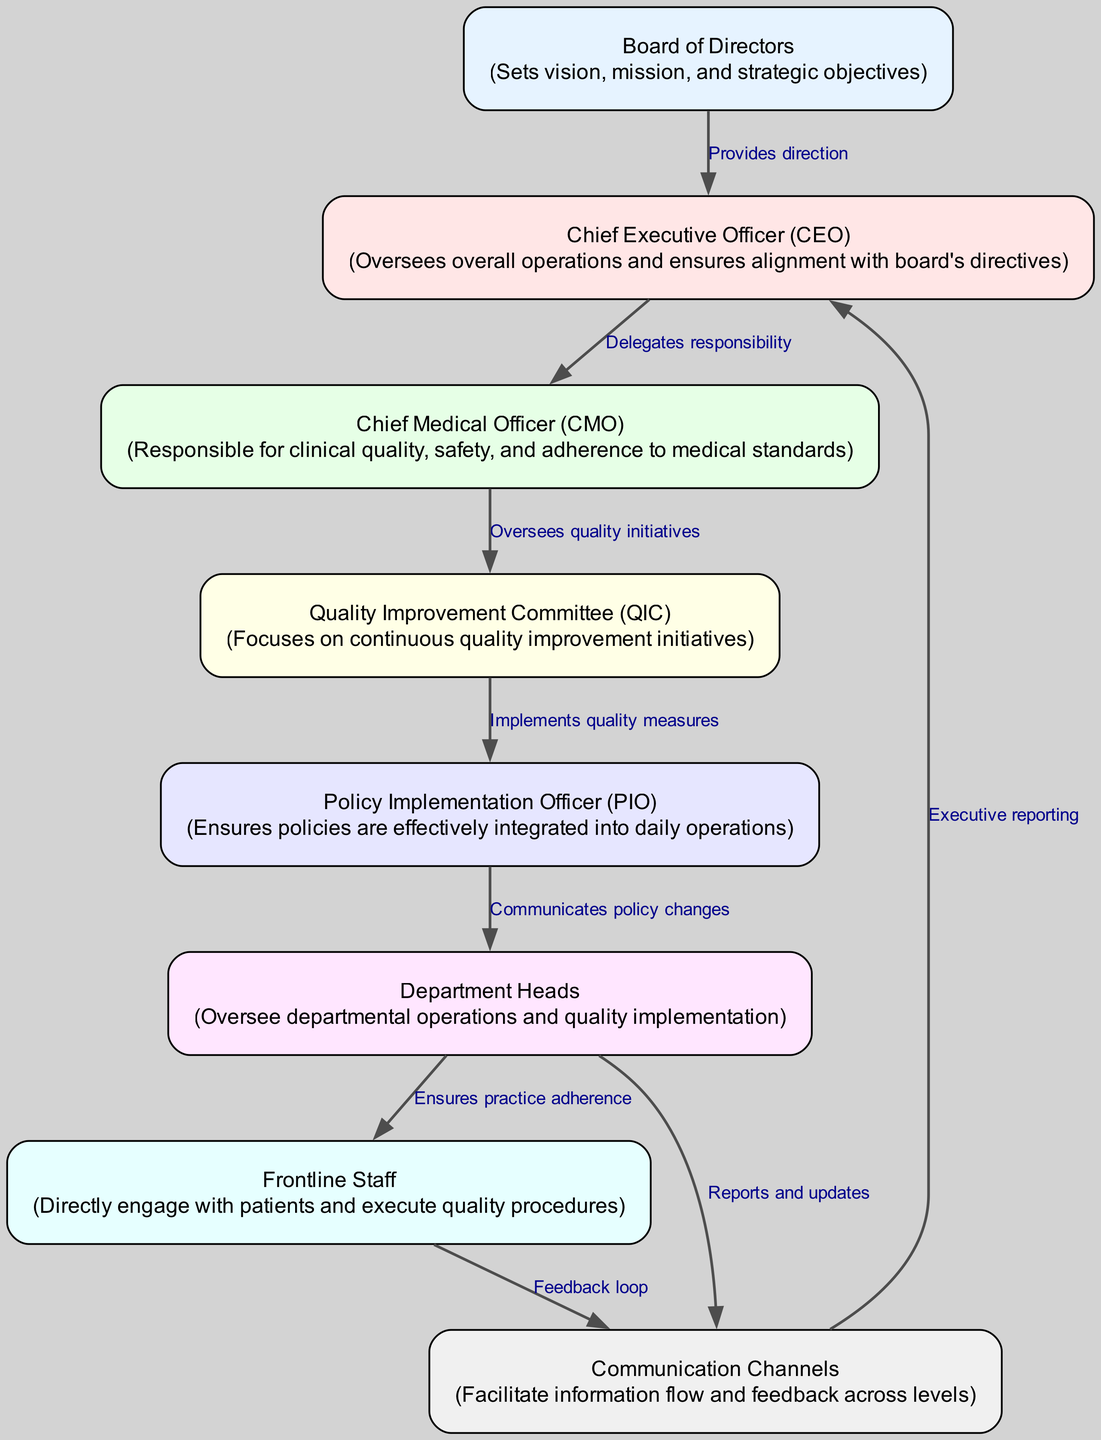What is the top-level governance body in the facility? The diagram clearly identifies the "Board of Directors" at the highest level, indicating its role in setting the vision, mission, and strategic objectives for the healthcare facility.
Answer: Board of Directors How many communication channels are identified in the diagram? By evaluating the edges connected to the "Communication Channels" node, there are four visible links that indicate various types of communication - from "Frontline Staff," from "Department Heads," and to "CEO." Hence, the total is recorded as four distinct channels.
Answer: 4 Who oversees clinical quality and safety in the facility? The "Chief Medical Officer (CMO)" node is connected to the "Quality Improvement Committee (QIC)" and is specifically described as being responsible for clinical quality, safety, and adherence to medical standards, denoting this role clearly.
Answer: Chief Medical Officer (CMO) What is the function of the Policy Implementation Officer (PIO)? The description linked to the "Policy Implementation Officer (PIO)" node indicates that this role is focused on ensuring that policies are effectively integrated into daily operations, which directly connects to the implementation aspect of quality improvement.
Answer: Ensures policies are effectively integrated Which role has a direct link to frontline staff? The "Department Heads" node has a direct edge leading to the "Frontline Staff" node, signifying their responsibility to oversee practice adherence, thus highlighting their role in influencing frontline operations.
Answer: Department Heads How does information flow from the Quality Improvement Committee to the Policy Implementation Officer? The diagram illustrates that the "Quality Improvement Committee (QIC)" directly oversees and provides direction to the "Policy Implementation Officer (PIO)," thereby facilitating the implementation of quality measures led by the QIC's initiatives.
Answer: Oversees quality initiatives What type of reporting is conducted from the communication channels to the CEO? The diagram indicates that the "Communication Channels" node has a directed edge leading to the "CEO" node labeled as "Executive reporting," which specifies the nature of information relayed to the CEO from communication pathways.
Answer: Executive reporting 